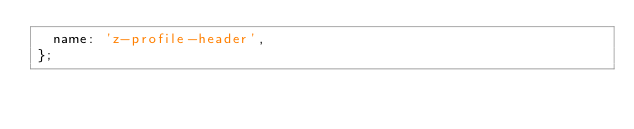<code> <loc_0><loc_0><loc_500><loc_500><_JavaScript_>  name: 'z-profile-header',
};</code> 